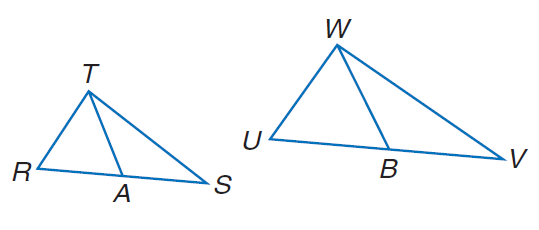Question: Find U B if \triangle R S T \sim \triangle U V W, T A and W B are medians, T A = 8, R A = 3, W B = 3 x - 6, and U B = x + 2.
Choices:
A. 24
B. 28
C. 32
D. 36
Answer with the letter. Answer: D 